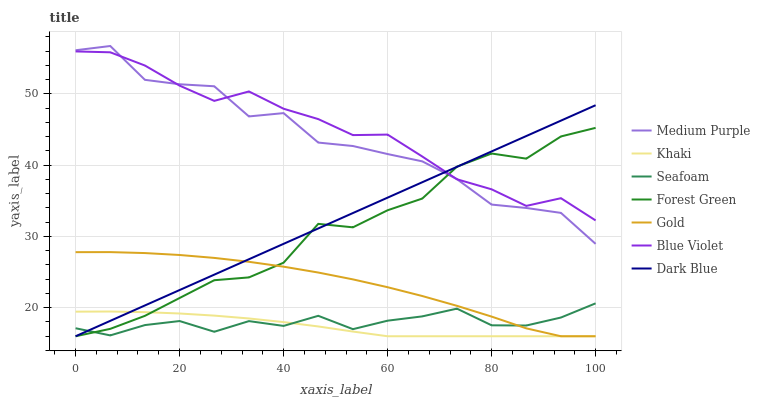Does Khaki have the minimum area under the curve?
Answer yes or no. Yes. Does Blue Violet have the maximum area under the curve?
Answer yes or no. Yes. Does Gold have the minimum area under the curve?
Answer yes or no. No. Does Gold have the maximum area under the curve?
Answer yes or no. No. Is Dark Blue the smoothest?
Answer yes or no. Yes. Is Medium Purple the roughest?
Answer yes or no. Yes. Is Gold the smoothest?
Answer yes or no. No. Is Gold the roughest?
Answer yes or no. No. Does Khaki have the lowest value?
Answer yes or no. Yes. Does Seafoam have the lowest value?
Answer yes or no. No. Does Medium Purple have the highest value?
Answer yes or no. Yes. Does Gold have the highest value?
Answer yes or no. No. Is Khaki less than Blue Violet?
Answer yes or no. Yes. Is Blue Violet greater than Gold?
Answer yes or no. Yes. Does Medium Purple intersect Blue Violet?
Answer yes or no. Yes. Is Medium Purple less than Blue Violet?
Answer yes or no. No. Is Medium Purple greater than Blue Violet?
Answer yes or no. No. Does Khaki intersect Blue Violet?
Answer yes or no. No. 